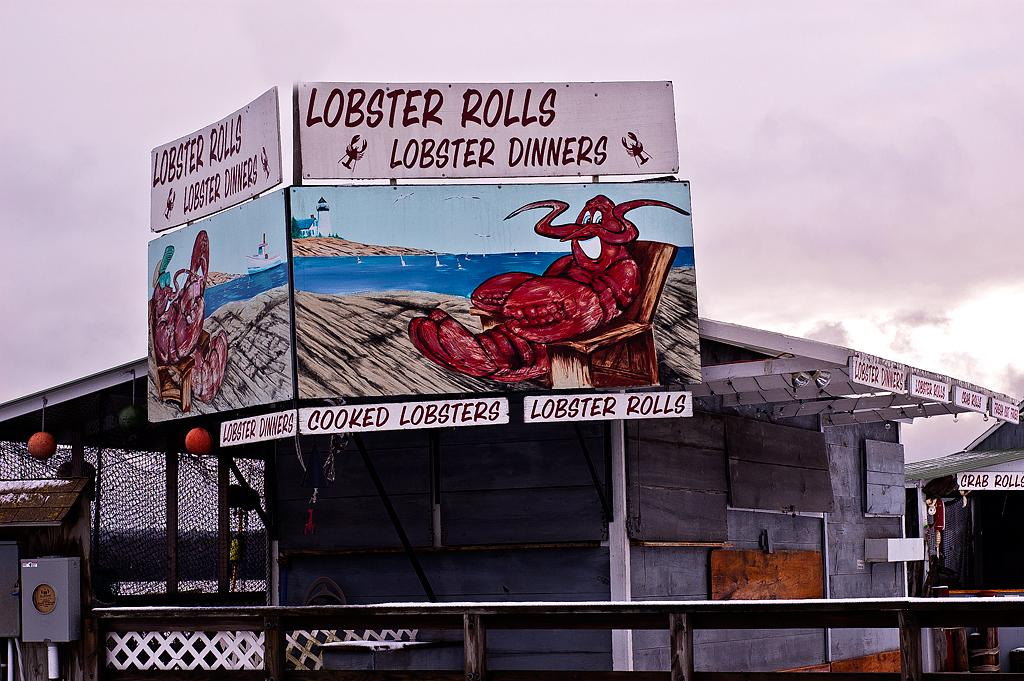<image>
Create a compact narrative representing the image presented. A sign that says Lobster Rolls is on a grey building. 